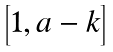Convert formula to latex. <formula><loc_0><loc_0><loc_500><loc_500>\begin{bmatrix} 1 , a - k \end{bmatrix}</formula> 